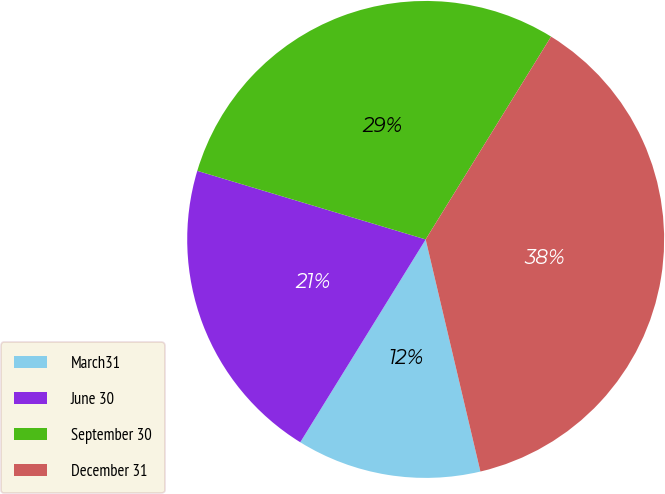Convert chart to OTSL. <chart><loc_0><loc_0><loc_500><loc_500><pie_chart><fcel>March31<fcel>June 30<fcel>September 30<fcel>December 31<nl><fcel>12.5%<fcel>20.83%<fcel>29.17%<fcel>37.5%<nl></chart> 